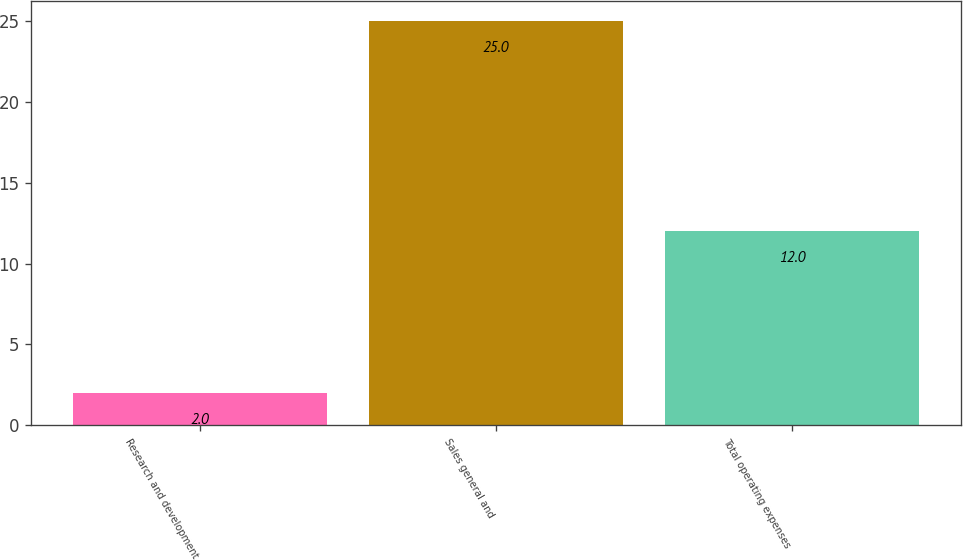Convert chart. <chart><loc_0><loc_0><loc_500><loc_500><bar_chart><fcel>Research and development<fcel>Sales general and<fcel>Total operating expenses<nl><fcel>2<fcel>25<fcel>12<nl></chart> 